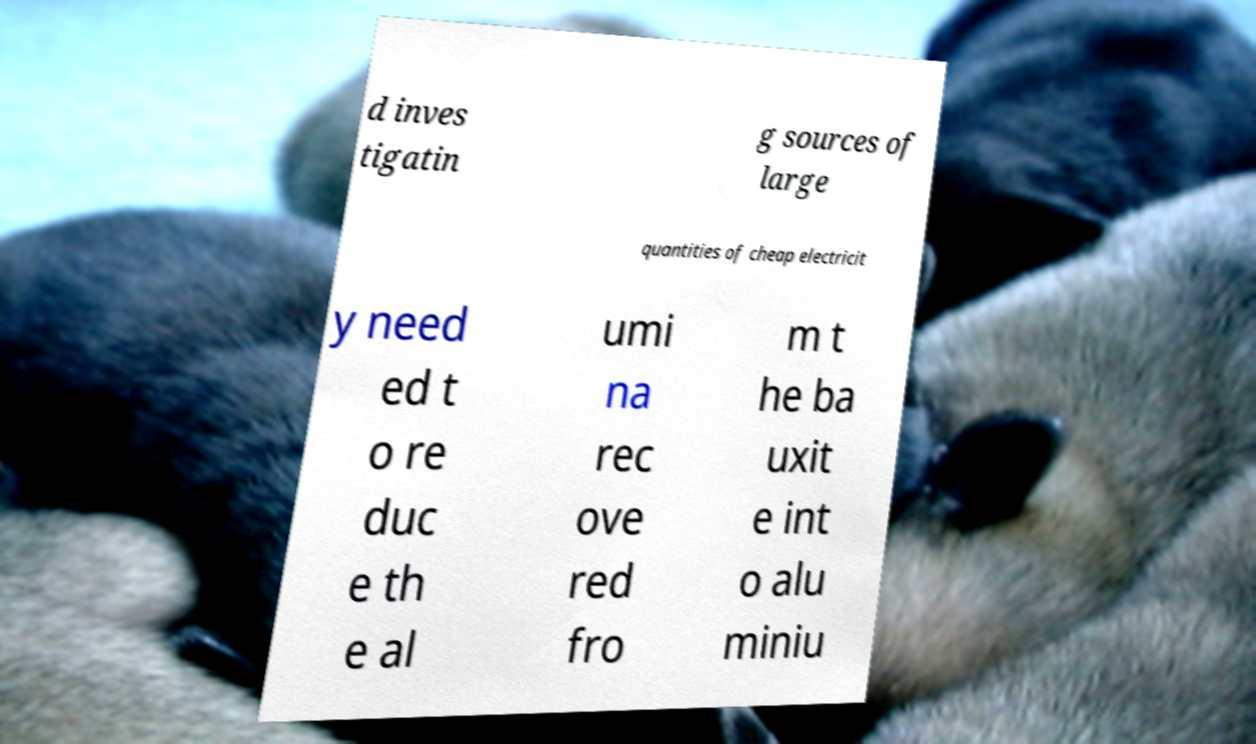There's text embedded in this image that I need extracted. Can you transcribe it verbatim? d inves tigatin g sources of large quantities of cheap electricit y need ed t o re duc e th e al umi na rec ove red fro m t he ba uxit e int o alu miniu 